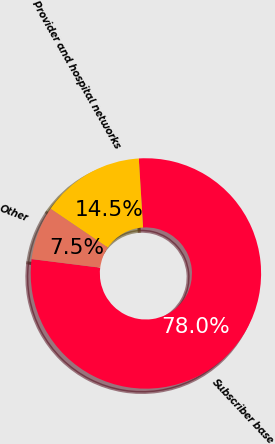<chart> <loc_0><loc_0><loc_500><loc_500><pie_chart><fcel>Subscriber base<fcel>Provider and hospital networks<fcel>Other<nl><fcel>77.98%<fcel>14.54%<fcel>7.49%<nl></chart> 